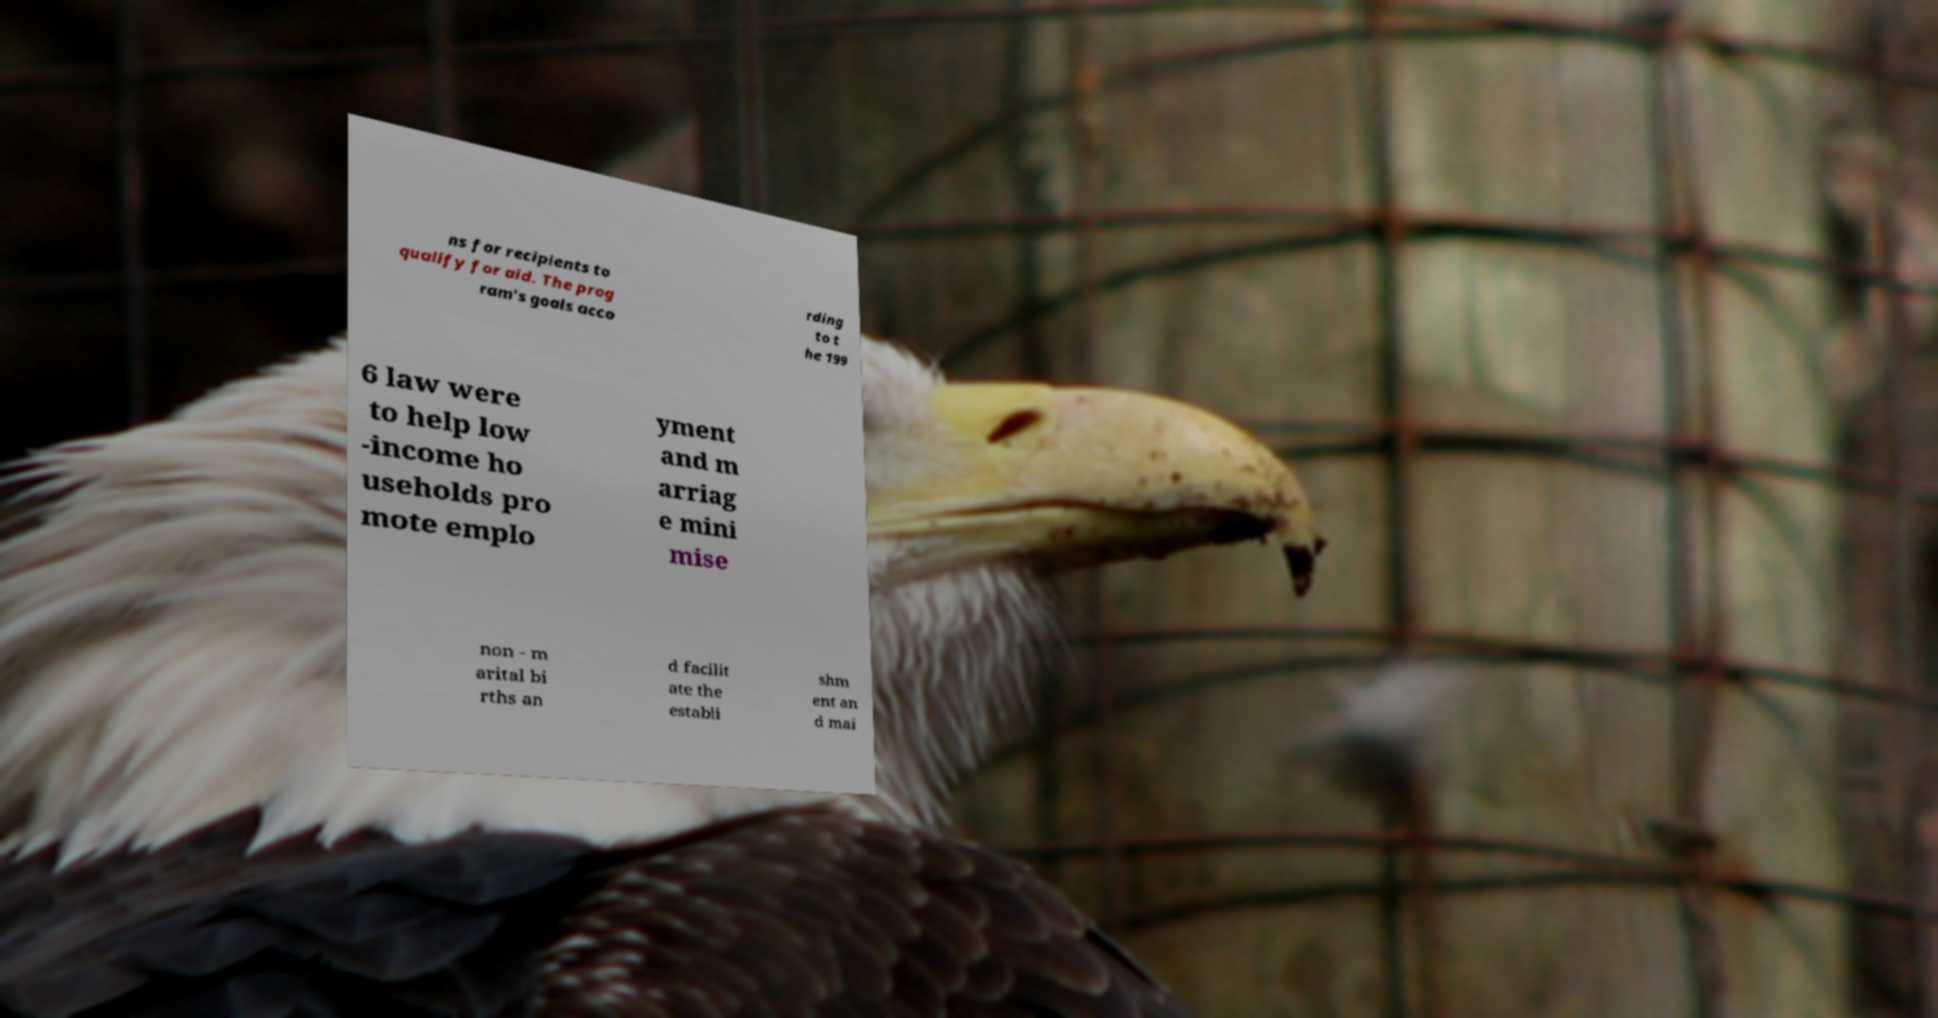Please read and relay the text visible in this image. What does it say? ns for recipients to qualify for aid. The prog ram's goals acco rding to t he 199 6 law were to help low -income ho useholds pro mote emplo yment and m arriag e mini mise non - m arital bi rths an d facilit ate the establi shm ent an d mai 